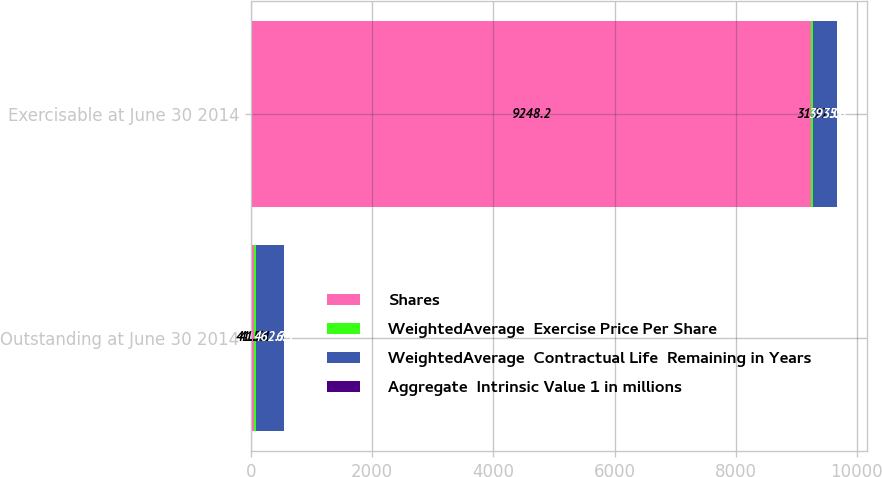Convert chart. <chart><loc_0><loc_0><loc_500><loc_500><stacked_bar_chart><ecel><fcel>Outstanding at June 30 2014<fcel>Exercisable at June 30 2014<nl><fcel>Shares<fcel>41.51<fcel>9248.2<nl><fcel>WeightedAverage  Exercise Price Per Share<fcel>41.51<fcel>31.77<nl><fcel>WeightedAverage  Contractual Life  Remaining in Years<fcel>462.7<fcel>393<nl><fcel>Aggregate  Intrinsic Value 1 in millions<fcel>6.5<fcel>5.6<nl></chart> 